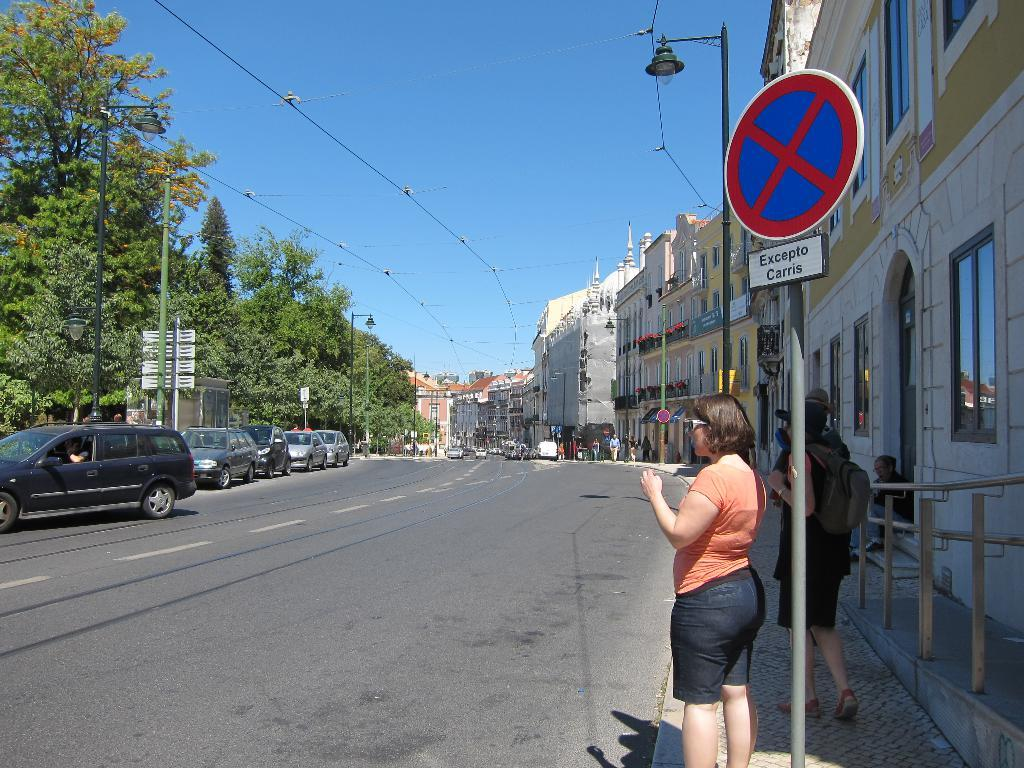How many women are in the image? There are two women standing in the image. What can be seen in the background of the image? There are buildings in a row in the background. What type of vehicles are parked in the image? Cars are parked on the side of the image. What kind of vegetation is visible around the scene? Trees are visible around the scene. What is present in the image for providing information or directions? There is a sign board present in the image. What type of powder is being used by the women in the image? There is no powder visible in the image, and the women are not performing any activity that would involve using powder. 